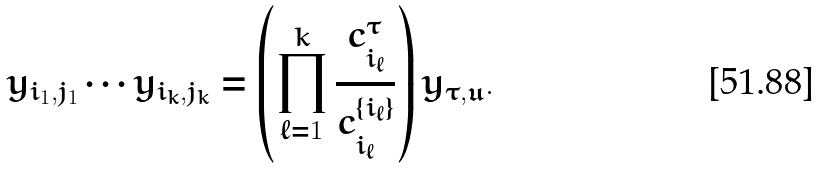Convert formula to latex. <formula><loc_0><loc_0><loc_500><loc_500>y _ { i _ { 1 } , j _ { 1 } } \cdots y _ { i _ { k } , j _ { k } } = \left ( \prod ^ { k } _ { \ell = 1 } \frac { c _ { i _ { \ell } } ^ { \tau } } { c _ { i _ { \ell } } ^ { \{ i _ { \ell } \} } } \right ) y _ { \tau , \mathfrak { u } } .</formula> 